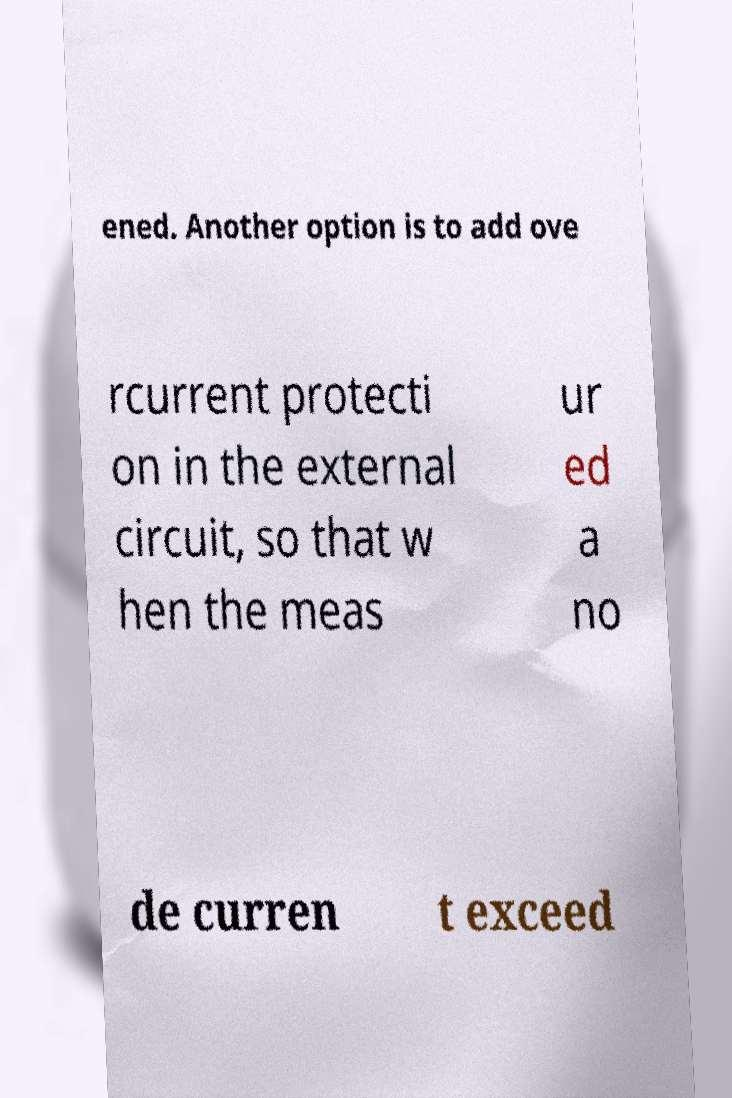Could you assist in decoding the text presented in this image and type it out clearly? ened. Another option is to add ove rcurrent protecti on in the external circuit, so that w hen the meas ur ed a no de curren t exceed 